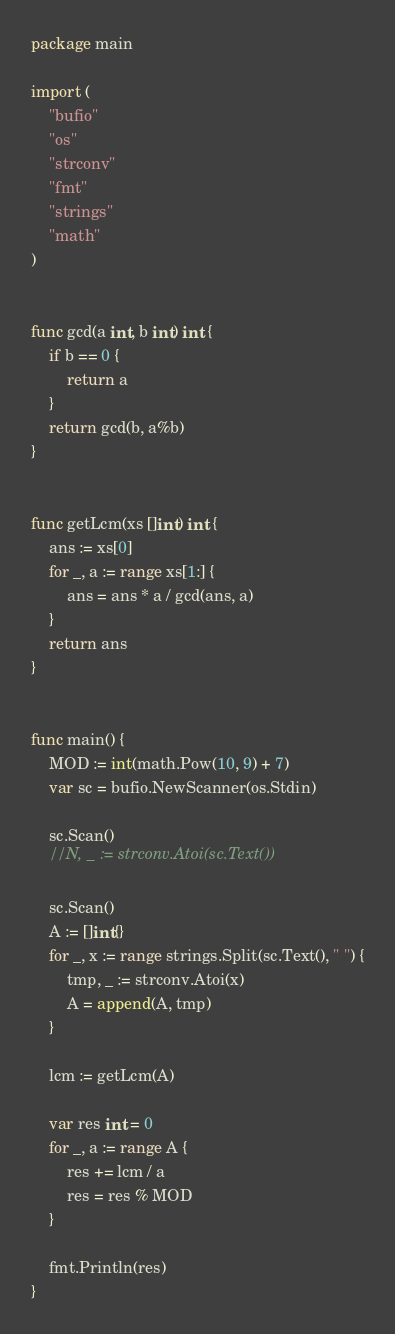Convert code to text. <code><loc_0><loc_0><loc_500><loc_500><_Go_>package main

import (
	"bufio"
	"os"
	"strconv"
	"fmt"
	"strings"
	"math"
)


func gcd(a int, b int) int {
    if b == 0 {
        return a
    }
    return gcd(b, a%b)
}


func getLcm(xs []int) int {
    ans := xs[0]
    for _, a := range xs[1:] {
		ans = ans * a / gcd(ans, a)
	}
	return ans
}


func main() {
	MOD := int(math.Pow(10, 9) + 7)
	var sc = bufio.NewScanner(os.Stdin)

	sc.Scan()
	//N, _ := strconv.Atoi(sc.Text())

	sc.Scan()
	A := []int{}
	for _, x := range strings.Split(sc.Text(), " ") {
		tmp, _ := strconv.Atoi(x)
		A = append(A, tmp)
	}

	lcm := getLcm(A)

	var res int = 0
	for _, a := range A {
	    res += lcm / a
		res = res % MOD
	}

	fmt.Println(res)
}</code> 